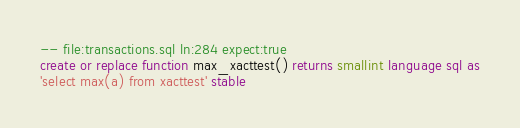<code> <loc_0><loc_0><loc_500><loc_500><_SQL_>-- file:transactions.sql ln:284 expect:true
create or replace function max_xacttest() returns smallint language sql as
'select max(a) from xacttest' stable
</code> 